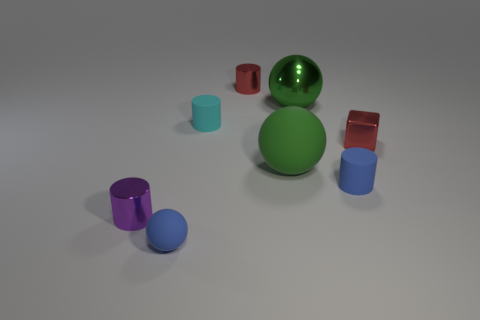What number of big things are blocks or cyan objects?
Ensure brevity in your answer.  0. What is the material of the tiny cyan thing that is the same shape as the purple thing?
Make the answer very short. Rubber. What is the color of the tiny metal cube?
Your answer should be compact. Red. Is the color of the metal ball the same as the large matte ball?
Keep it short and to the point. Yes. How many metallic cylinders are left of the blue thing that is to the left of the green metal thing?
Provide a succinct answer. 1. What is the size of the metal object that is in front of the small red cylinder and behind the red block?
Your answer should be very brief. Large. What is the small red object that is in front of the red cylinder made of?
Your response must be concise. Metal. Is there another brown rubber thing that has the same shape as the large rubber object?
Your answer should be very brief. No. How many small brown objects are the same shape as the cyan matte object?
Offer a terse response. 0. Is the size of the green object that is behind the tiny cyan rubber object the same as the blue object left of the tiny blue rubber cylinder?
Offer a very short reply. No. 